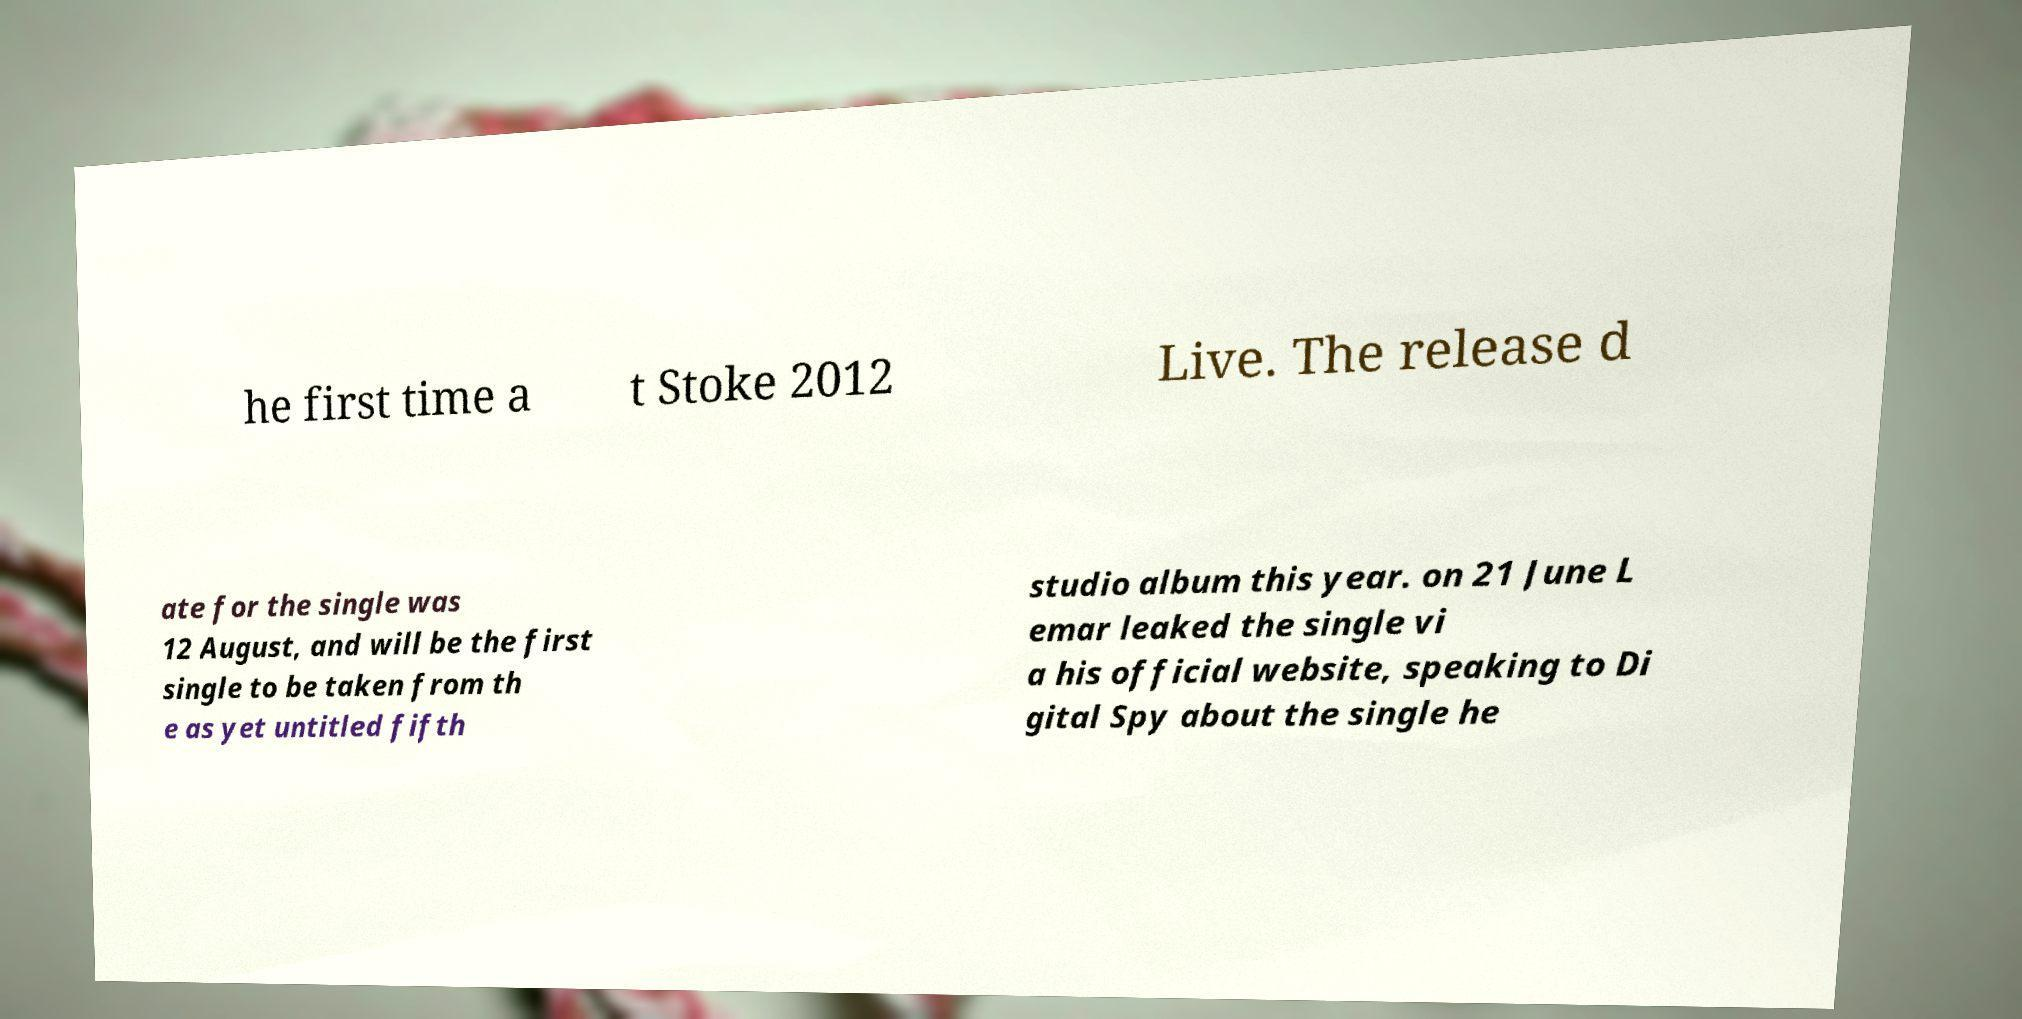Please read and relay the text visible in this image. What does it say? he first time a t Stoke 2012 Live. The release d ate for the single was 12 August, and will be the first single to be taken from th e as yet untitled fifth studio album this year. on 21 June L emar leaked the single vi a his official website, speaking to Di gital Spy about the single he 